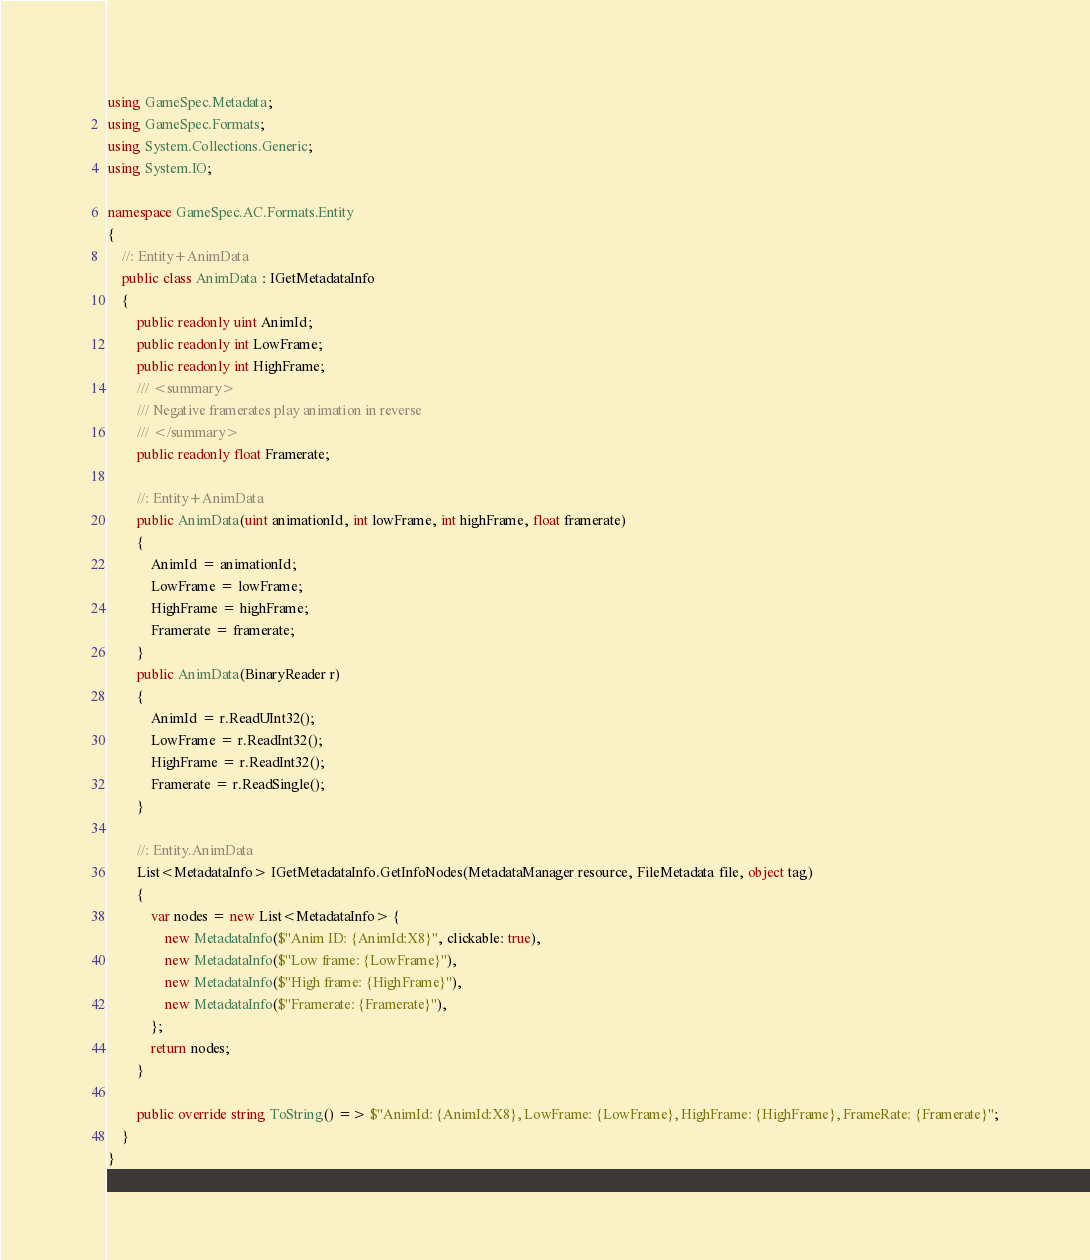Convert code to text. <code><loc_0><loc_0><loc_500><loc_500><_C#_>using GameSpec.Metadata;
using GameSpec.Formats;
using System.Collections.Generic;
using System.IO;

namespace GameSpec.AC.Formats.Entity
{
    //: Entity+AnimData
    public class AnimData : IGetMetadataInfo
    {
        public readonly uint AnimId;
        public readonly int LowFrame;
        public readonly int HighFrame;
        /// <summary>
        /// Negative framerates play animation in reverse
        /// </summary>
        public readonly float Framerate;

        //: Entity+AnimData
        public AnimData(uint animationId, int lowFrame, int highFrame, float framerate)
        {
            AnimId = animationId;
            LowFrame = lowFrame;
            HighFrame = highFrame;
            Framerate = framerate;
        }
        public AnimData(BinaryReader r)
        {
            AnimId = r.ReadUInt32();
            LowFrame = r.ReadInt32();
            HighFrame = r.ReadInt32();
            Framerate = r.ReadSingle();
        }

        //: Entity.AnimData
        List<MetadataInfo> IGetMetadataInfo.GetInfoNodes(MetadataManager resource, FileMetadata file, object tag)
        {
            var nodes = new List<MetadataInfo> {
                new MetadataInfo($"Anim ID: {AnimId:X8}", clickable: true),
                new MetadataInfo($"Low frame: {LowFrame}"),
                new MetadataInfo($"High frame: {HighFrame}"),
                new MetadataInfo($"Framerate: {Framerate}"),
            };
            return nodes;
        }

        public override string ToString() => $"AnimId: {AnimId:X8}, LowFrame: {LowFrame}, HighFrame: {HighFrame}, FrameRate: {Framerate}";
    }
}
</code> 